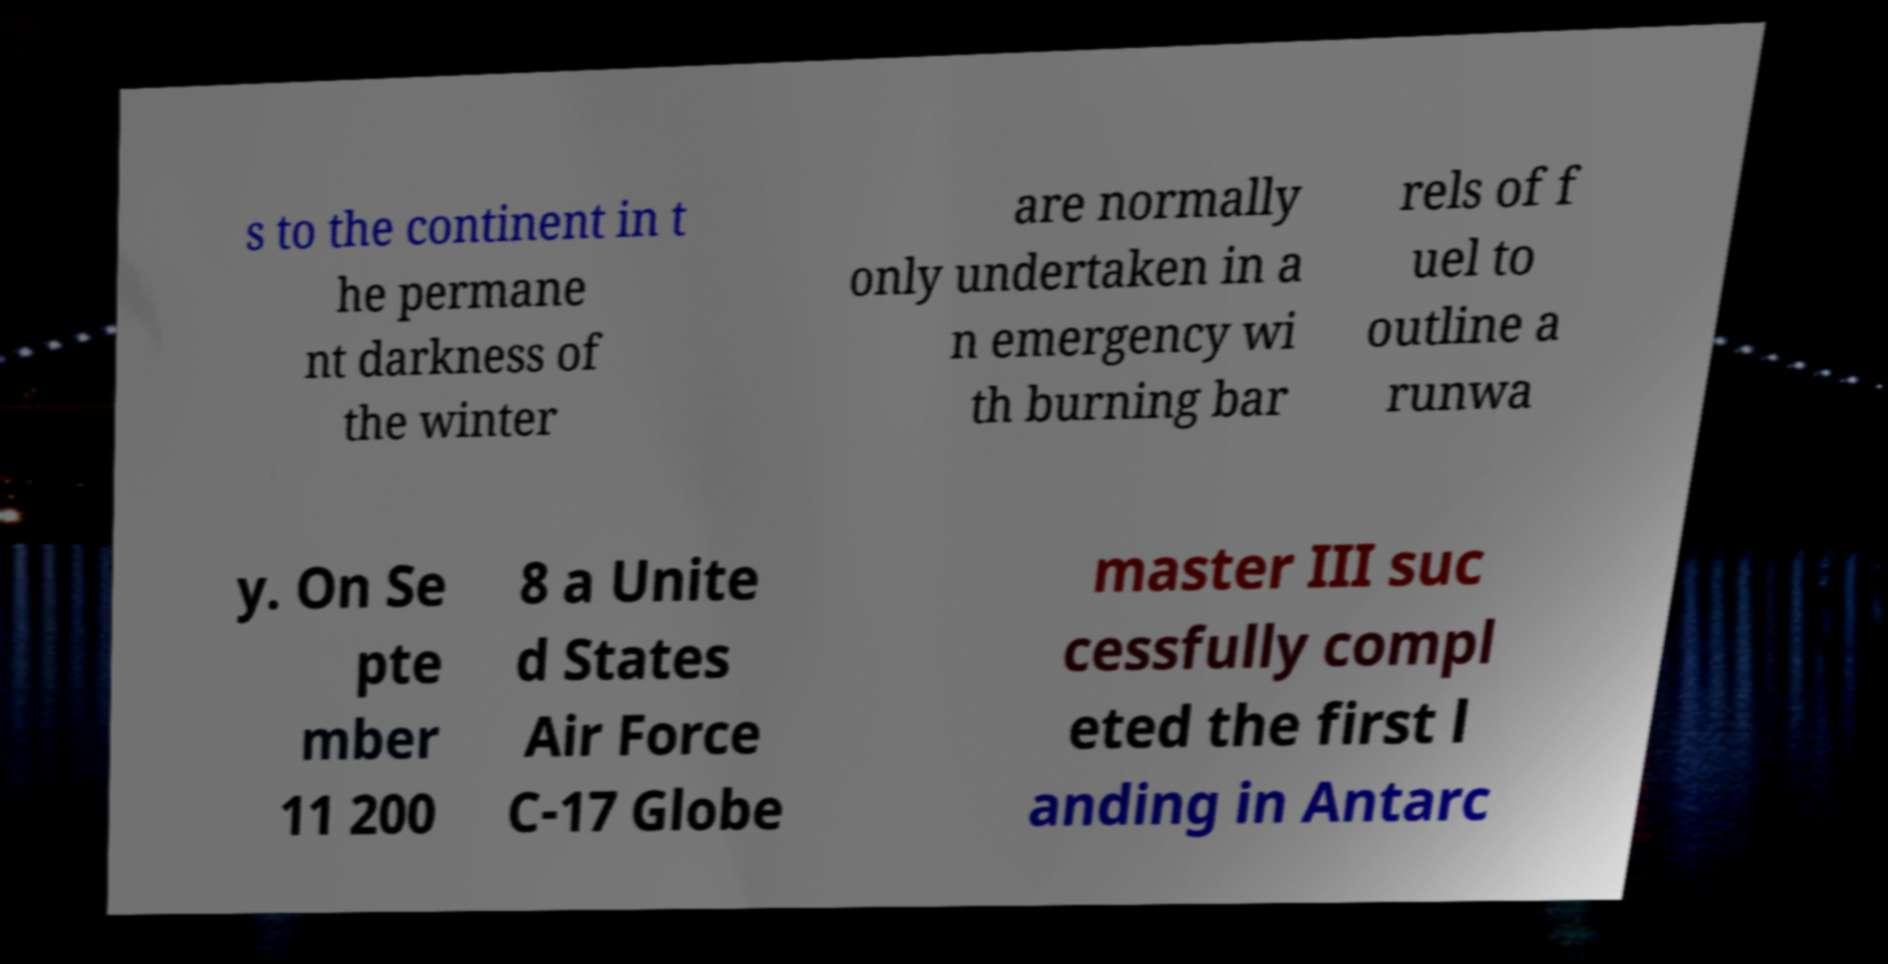Could you assist in decoding the text presented in this image and type it out clearly? s to the continent in t he permane nt darkness of the winter are normally only undertaken in a n emergency wi th burning bar rels of f uel to outline a runwa y. On Se pte mber 11 200 8 a Unite d States Air Force C-17 Globe master III suc cessfully compl eted the first l anding in Antarc 